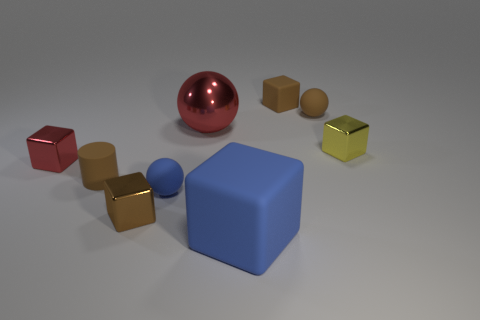Subtract 1 balls. How many balls are left? 2 Subtract all blue blocks. How many blocks are left? 4 Subtract all tiny yellow metal cubes. How many cubes are left? 4 Subtract all purple cubes. Subtract all purple spheres. How many cubes are left? 5 Add 1 brown cubes. How many objects exist? 10 Subtract all blocks. How many objects are left? 4 Add 6 yellow objects. How many yellow objects are left? 7 Add 6 blue metal spheres. How many blue metal spheres exist? 6 Subtract 0 purple cylinders. How many objects are left? 9 Subtract all tiny rubber cubes. Subtract all tiny spheres. How many objects are left? 6 